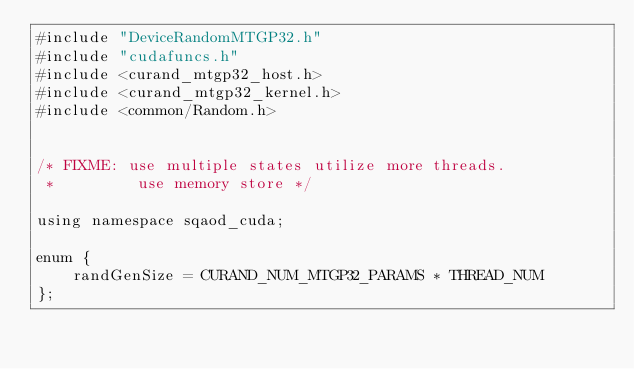Convert code to text. <code><loc_0><loc_0><loc_500><loc_500><_Cuda_>#include "DeviceRandomMTGP32.h"
#include "cudafuncs.h"
#include <curand_mtgp32_host.h>
#include <curand_mtgp32_kernel.h>
#include <common/Random.h>


/* FIXME: use multiple states utilize more threads.
 *         use memory store */

using namespace sqaod_cuda;
    
enum {
    randGenSize = CURAND_NUM_MTGP32_PARAMS * THREAD_NUM
};

</code> 